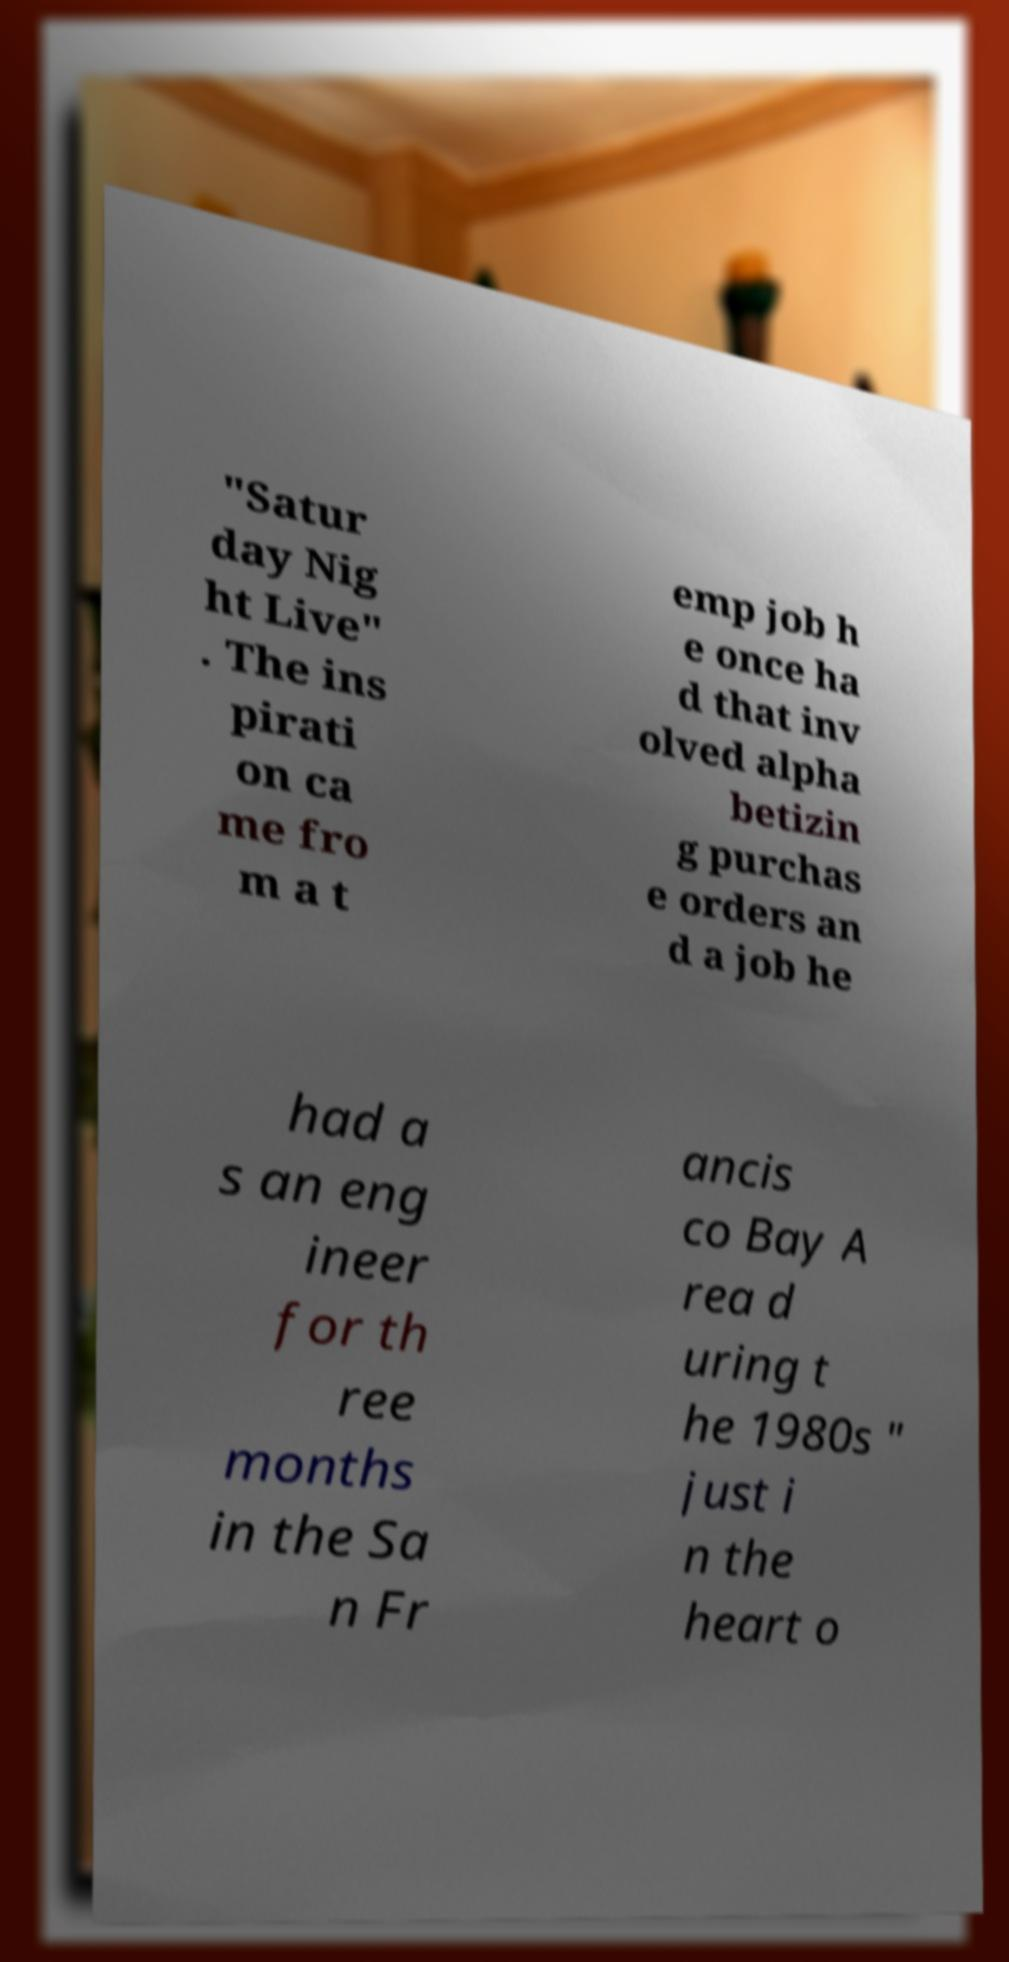Please read and relay the text visible in this image. What does it say? "Satur day Nig ht Live" . The ins pirati on ca me fro m a t emp job h e once ha d that inv olved alpha betizin g purchas e orders an d a job he had a s an eng ineer for th ree months in the Sa n Fr ancis co Bay A rea d uring t he 1980s " just i n the heart o 